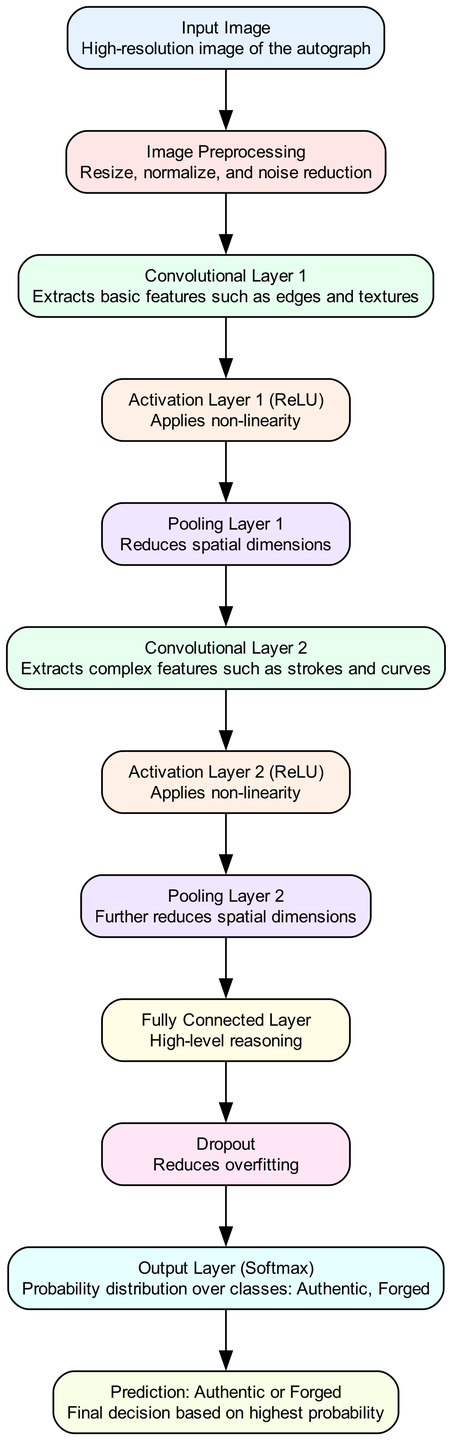What is the first node in the diagram? The first node in the diagram is labeled 'Input Image', which represents the high-resolution image of the autograph.
Answer: Input Image How many convolutional layers are present in the diagram? There are two convolutional layers labeled 'Convolutional Layer 1' and 'Convolutional Layer 2', indicating the total number of convolutional layers in the model.
Answer: 2 What label is associated with the output layer? The output layer is labeled 'Output Layer (Softmax)', which indicates that this layer generates a probability distribution over the classes.
Answer: Output Layer (Softmax) Which layer follows the first pooling layer? The layer that follows the first pooling layer is 'Convolutional Layer 2', showing the sequence of processing after the first pooling operation.
Answer: Convolutional Layer 2 What is the purpose of the Dropout layer? The Dropout layer is used to reduce overfitting, which helps to improve the generalization of the model by randomly dropping a portion of neurons during training.
Answer: Reduces overfitting What type of features does Convolutional Layer 1 extract? Convolutional Layer 1 extracts basic features such as edges and textures, which are essential for initial image analysis.
Answer: Basic features like edges and textures Where does the final decision about authenticity occur? The final decision about authenticity takes place in the 'Prediction: Authentic or Forged' node, where the model classifies the signature based on the highest probability.
Answer: Prediction: Authentic or Forged What is the main role of the Fully Connected Layer? The Fully Connected Layer is responsible for high-level reasoning in the model, integrating features learned from previous layers to make a final classification.
Answer: High-level reasoning How many edges connect the nodes in the diagram? The total number of edges in the diagram is eleven, representing the connections that guide the flow from node to node.
Answer: 11 